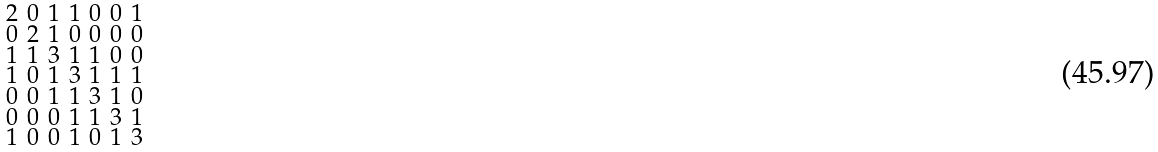Convert formula to latex. <formula><loc_0><loc_0><loc_500><loc_500>\begin{smallmatrix} 2 & 0 & 1 & 1 & 0 & 0 & 1 \\ 0 & 2 & 1 & 0 & 0 & 0 & 0 \\ 1 & 1 & 3 & 1 & 1 & 0 & 0 \\ 1 & 0 & 1 & 3 & 1 & 1 & 1 \\ 0 & 0 & 1 & 1 & 3 & 1 & 0 \\ 0 & 0 & 0 & 1 & 1 & 3 & 1 \\ 1 & 0 & 0 & 1 & 0 & 1 & 3 \end{smallmatrix}</formula> 